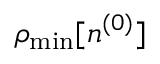<formula> <loc_0><loc_0><loc_500><loc_500>\rho _ { \min } [ n ^ { ( 0 ) } ]</formula> 